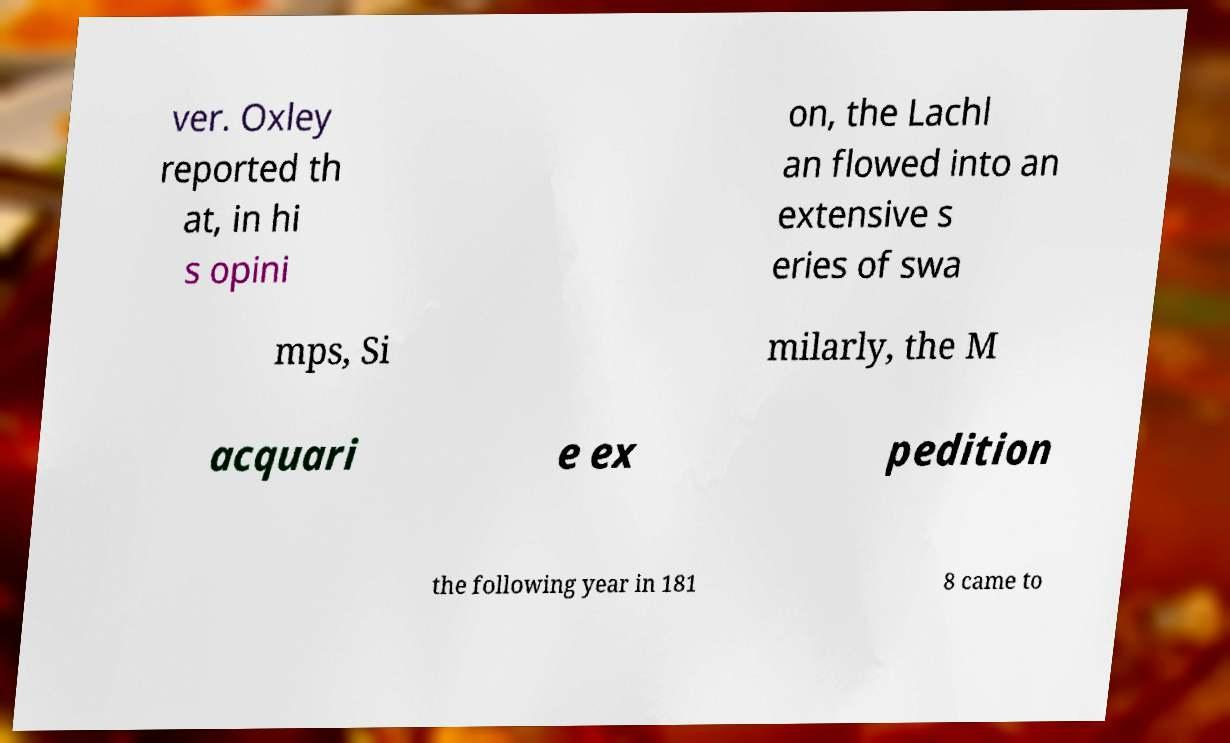Can you read and provide the text displayed in the image?This photo seems to have some interesting text. Can you extract and type it out for me? ver. Oxley reported th at, in hi s opini on, the Lachl an flowed into an extensive s eries of swa mps, Si milarly, the M acquari e ex pedition the following year in 181 8 came to 